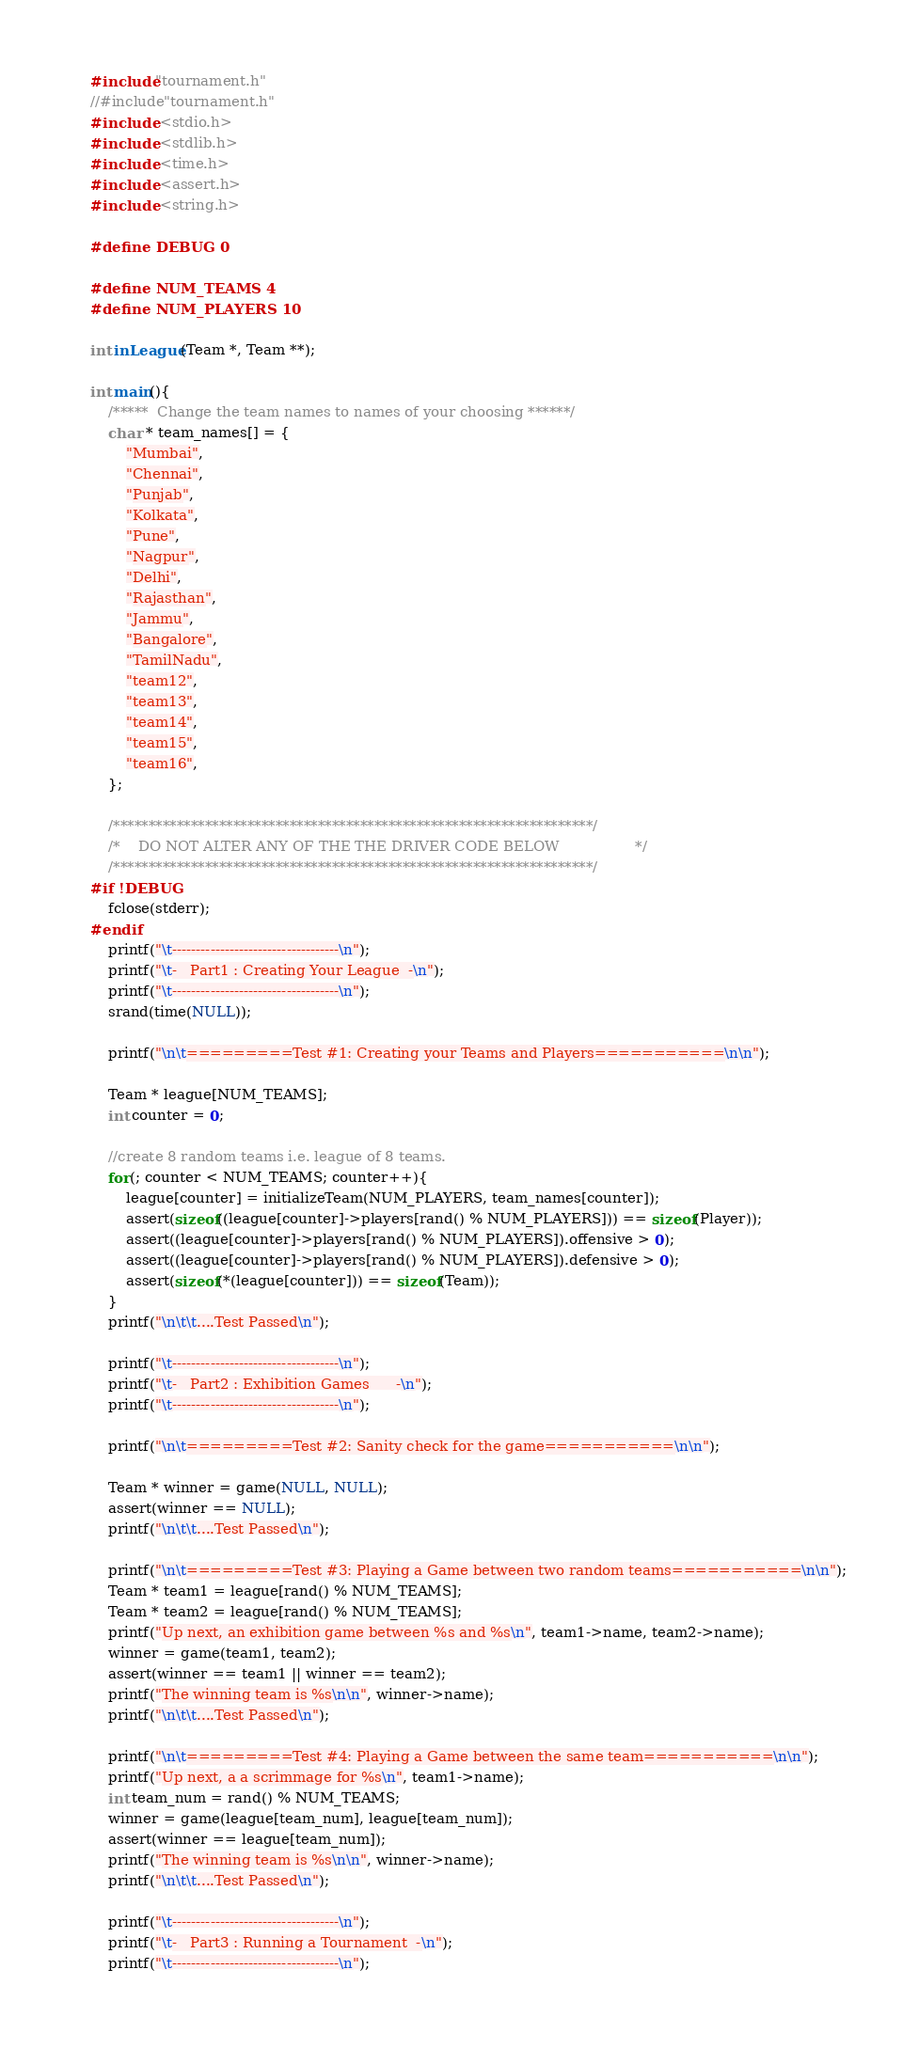Convert code to text. <code><loc_0><loc_0><loc_500><loc_500><_C_>#include"tournament.h"
//#include"tournament.h"
#include <stdio.h>
#include <stdlib.h>
#include <time.h>
#include <assert.h>
#include <string.h>

#define DEBUG 0

#define NUM_TEAMS 4
#define NUM_PLAYERS 10

int inLeague(Team *, Team **);

int main(){
    /*****  Change the team names to names of your choosing ******/
    char * team_names[] = {
        "Mumbai",
        "Chennai",
        "Punjab",
        "Kolkata",
        "Pune",
        "Nagpur",
        "Delhi",
        "Rajasthan",
        "Jammu",
        "Bangalore",
        "TamilNadu",
        "team12",
        "team13",
        "team14",
        "team15",
        "team16",
    };

    /********************************************************************/
    /*    DO NOT ALTER ANY OF THE THE DRIVER CODE BELOW                 */
    /********************************************************************/
#if !DEBUG
    fclose(stderr);
#endif
    printf("\t-----------------------------------\n");
    printf("\t-   Part1 : Creating Your League  -\n");
    printf("\t-----------------------------------\n");
    srand(time(NULL));

    printf("\n\t=========Test #1: Creating your Teams and Players===========\n\n");

    Team * league[NUM_TEAMS];
    int counter = 0;

    //create 8 random teams i.e. league of 8 teams.
    for(; counter < NUM_TEAMS; counter++){
        league[counter] = initializeTeam(NUM_PLAYERS, team_names[counter]);
        assert(sizeof((league[counter]->players[rand() % NUM_PLAYERS])) == sizeof(Player));
        assert((league[counter]->players[rand() % NUM_PLAYERS]).offensive > 0);
        assert((league[counter]->players[rand() % NUM_PLAYERS]).defensive > 0);
        assert(sizeof(*(league[counter])) == sizeof(Team));
    }
    printf("\n\t\t....Test Passed\n");

    printf("\t-----------------------------------\n");
    printf("\t-   Part2 : Exhibition Games      -\n");
    printf("\t-----------------------------------\n");

    printf("\n\t=========Test #2: Sanity check for the game===========\n\n");

    Team * winner = game(NULL, NULL);
    assert(winner == NULL);
    printf("\n\t\t....Test Passed\n");

    printf("\n\t=========Test #3: Playing a Game between two random teams===========\n\n");
    Team * team1 = league[rand() % NUM_TEAMS];
    Team * team2 = league[rand() % NUM_TEAMS];
    printf("Up next, an exhibition game between %s and %s\n", team1->name, team2->name);
    winner = game(team1, team2);
    assert(winner == team1 || winner == team2);
    printf("The winning team is %s\n\n", winner->name);
    printf("\n\t\t....Test Passed\n");

    printf("\n\t=========Test #4: Playing a Game between the same team===========\n\n");
    printf("Up next, a a scrimmage for %s\n", team1->name);
    int team_num = rand() % NUM_TEAMS;
    winner = game(league[team_num], league[team_num]);
    assert(winner == league[team_num]);
    printf("The winning team is %s\n\n", winner->name);
    printf("\n\t\t....Test Passed\n");

    printf("\t-----------------------------------\n");
    printf("\t-   Part3 : Running a Tournament  -\n");
    printf("\t-----------------------------------\n");</code> 